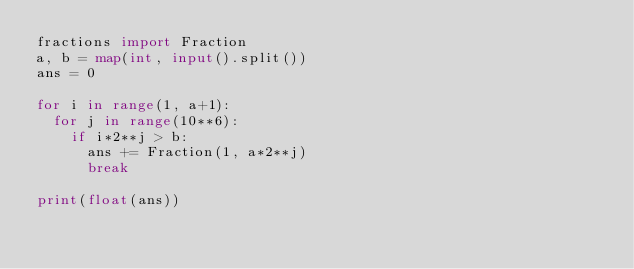<code> <loc_0><loc_0><loc_500><loc_500><_Python_>fractions import Fraction
a, b = map(int, input().split())
ans = 0

for i in range(1, a+1):
  for j in range(10**6):
    if i*2**j > b:
      ans += Fraction(1, a*2**j)
      break

print(float(ans))</code> 